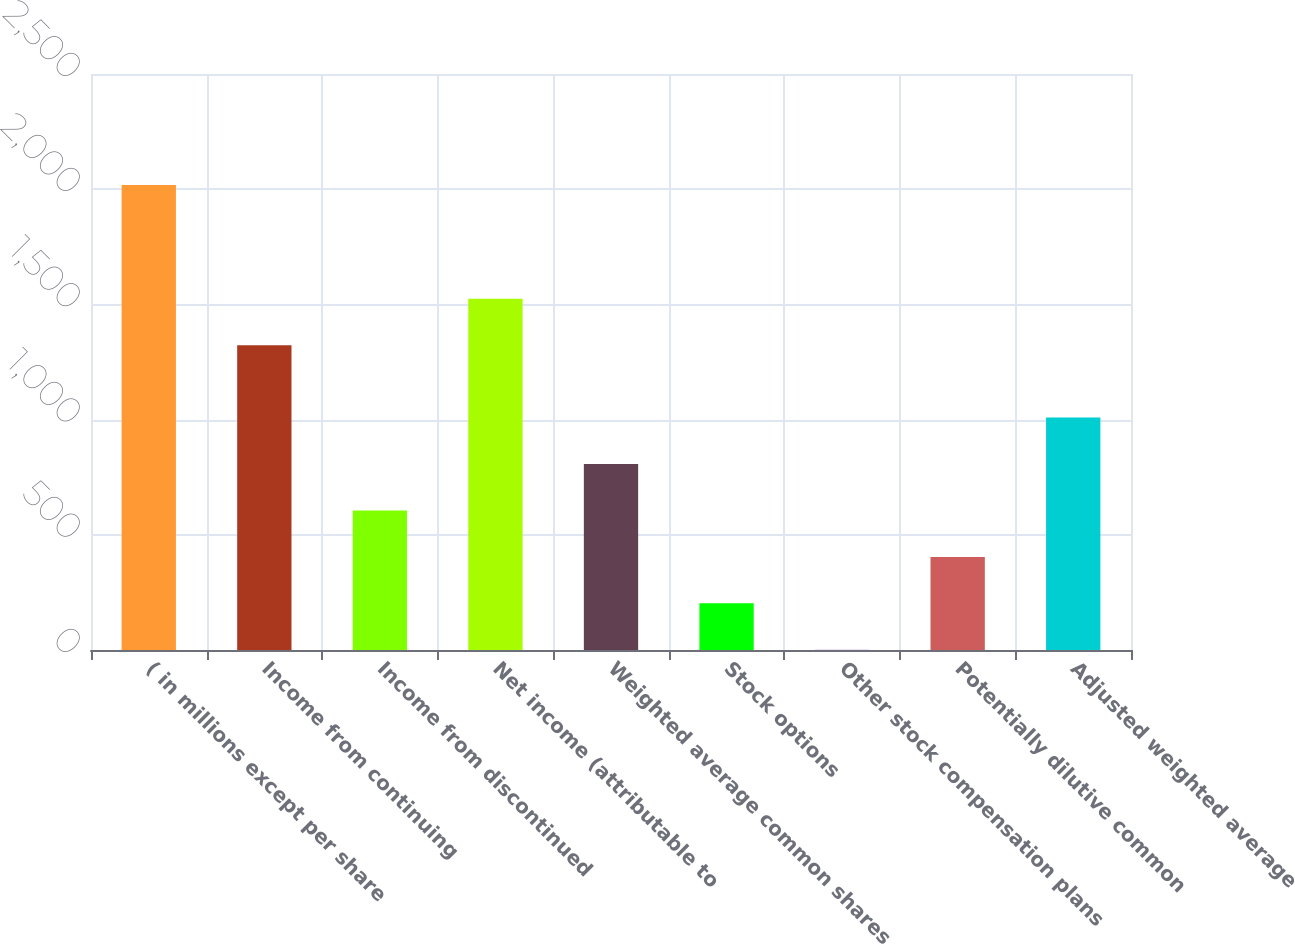<chart> <loc_0><loc_0><loc_500><loc_500><bar_chart><fcel>( in millions except per share<fcel>Income from continuing<fcel>Income from discontinued<fcel>Net income (attributable to<fcel>Weighted average common shares<fcel>Stock options<fcel>Other stock compensation plans<fcel>Potentially dilutive common<fcel>Adjusted weighted average<nl><fcel>2018<fcel>1323<fcel>605.89<fcel>1524.73<fcel>807.62<fcel>202.43<fcel>0.7<fcel>404.16<fcel>1009.35<nl></chart> 